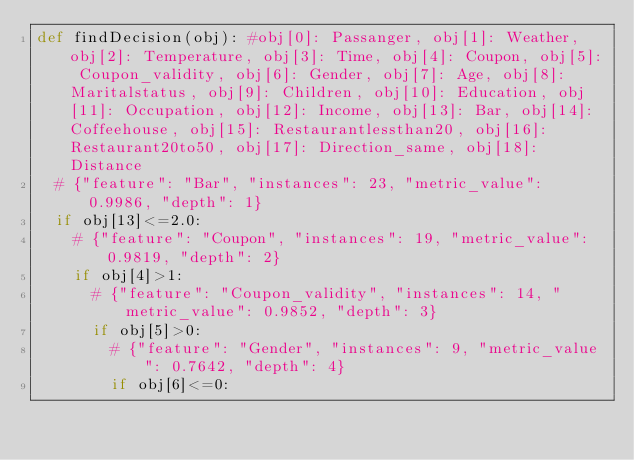<code> <loc_0><loc_0><loc_500><loc_500><_Python_>def findDecision(obj): #obj[0]: Passanger, obj[1]: Weather, obj[2]: Temperature, obj[3]: Time, obj[4]: Coupon, obj[5]: Coupon_validity, obj[6]: Gender, obj[7]: Age, obj[8]: Maritalstatus, obj[9]: Children, obj[10]: Education, obj[11]: Occupation, obj[12]: Income, obj[13]: Bar, obj[14]: Coffeehouse, obj[15]: Restaurantlessthan20, obj[16]: Restaurant20to50, obj[17]: Direction_same, obj[18]: Distance
	# {"feature": "Bar", "instances": 23, "metric_value": 0.9986, "depth": 1}
	if obj[13]<=2.0:
		# {"feature": "Coupon", "instances": 19, "metric_value": 0.9819, "depth": 2}
		if obj[4]>1:
			# {"feature": "Coupon_validity", "instances": 14, "metric_value": 0.9852, "depth": 3}
			if obj[5]>0:
				# {"feature": "Gender", "instances": 9, "metric_value": 0.7642, "depth": 4}
				if obj[6]<=0:</code> 